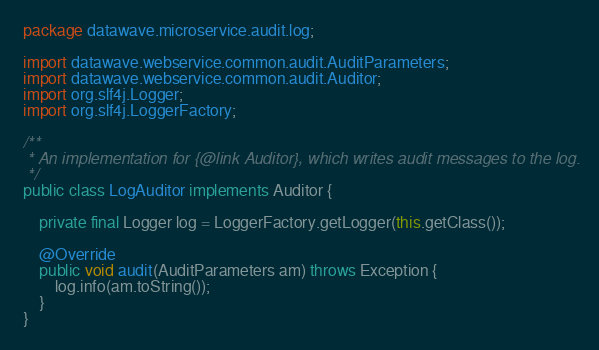Convert code to text. <code><loc_0><loc_0><loc_500><loc_500><_Java_>package datawave.microservice.audit.log;

import datawave.webservice.common.audit.AuditParameters;
import datawave.webservice.common.audit.Auditor;
import org.slf4j.Logger;
import org.slf4j.LoggerFactory;

/**
 * An implementation for {@link Auditor}, which writes audit messages to the log.
 */
public class LogAuditor implements Auditor {
    
    private final Logger log = LoggerFactory.getLogger(this.getClass());
    
    @Override
    public void audit(AuditParameters am) throws Exception {
        log.info(am.toString());
    }
}
</code> 